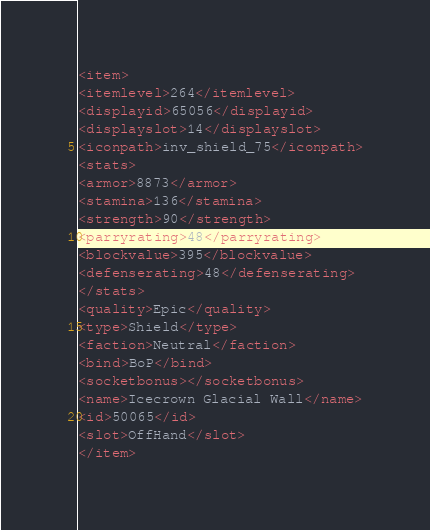<code> <loc_0><loc_0><loc_500><loc_500><_XML_><item>
<itemlevel>264</itemlevel>
<displayid>65056</displayid>
<displayslot>14</displayslot>
<iconpath>inv_shield_75</iconpath>
<stats>
<armor>8873</armor>
<stamina>136</stamina>
<strength>90</strength>
<parryrating>48</parryrating>
<blockvalue>395</blockvalue>
<defenserating>48</defenserating>
</stats>
<quality>Epic</quality>
<type>Shield</type>
<faction>Neutral</faction>
<bind>BoP</bind>
<socketbonus></socketbonus>
<name>Icecrown Glacial Wall</name>
<id>50065</id>
<slot>OffHand</slot>
</item></code> 